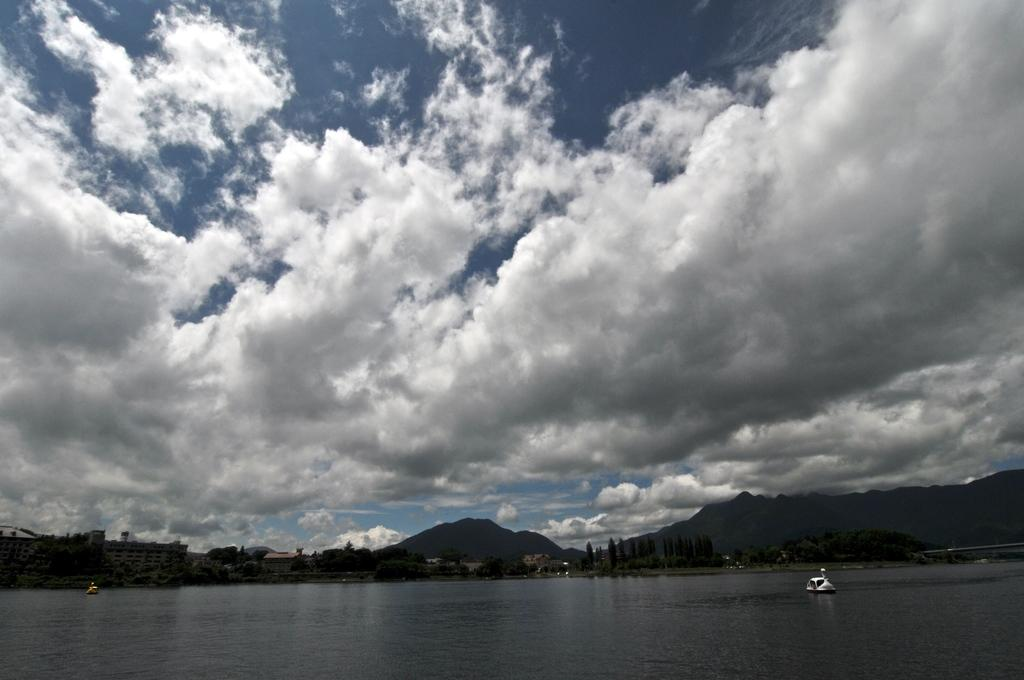What type of natural landform can be seen in the image? There are mountains in the image. What type of vegetation is present in the image? There are trees in the image. What type of man-made structures are visible in the image? There are buildings in the image. What is on the water surface in the image? There are objects on the water surface in the image. What colors are used to depict the sky in the image? The sky is in white and blue color in the image. Can you tell me how many twigs are present in the image? There is no mention of twigs in the image, so it is impossible to determine their number. What type of metal is used to construct the buildings in the image? The image does not provide information about the materials used to construct the buildings, so we cannot determine the type of metal used. 